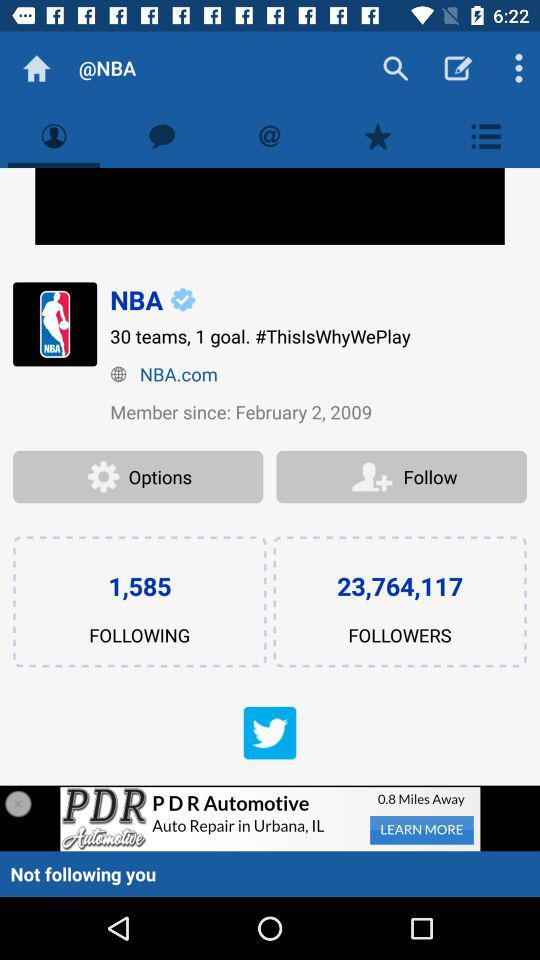How many followings are there? There are 1,585 followers. 